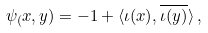<formula> <loc_0><loc_0><loc_500><loc_500>\psi _ { ( } x , y ) = - 1 + \langle \iota ( x ) , \overline { \iota ( y ) } \rangle \, ,</formula> 